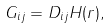<formula> <loc_0><loc_0><loc_500><loc_500>G _ { i j } = D _ { i j } H ( { r } ) ,</formula> 